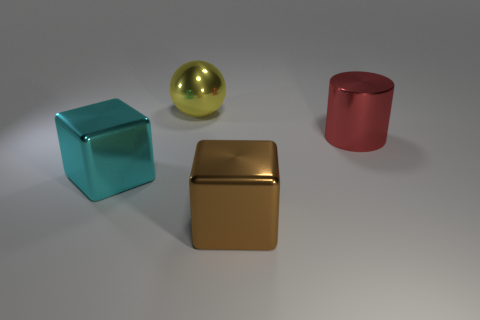Is there anything else that is the same shape as the cyan object?
Make the answer very short. Yes. The large sphere that is the same material as the large red object is what color?
Give a very brief answer. Yellow. How many objects are large green cylinders or large cubes?
Your answer should be very brief. 2. What color is the cube that is behind the big metal block that is to the right of the big block behind the brown cube?
Your response must be concise. Cyan. The large ball is what color?
Ensure brevity in your answer.  Yellow. Are there more big metallic objects in front of the big cyan object than large red objects behind the large brown metallic thing?
Your answer should be compact. No. Does the big brown metallic object have the same shape as the big metal object on the left side of the large metallic sphere?
Offer a very short reply. Yes. There is a metallic thing that is behind the cylinder; is it the same size as the metal cube on the left side of the big yellow shiny sphere?
Provide a succinct answer. Yes. There is a big metal block that is in front of the object that is left of the large yellow sphere; is there a brown shiny object on the right side of it?
Keep it short and to the point. No. Are there fewer brown objects that are left of the large yellow metal object than large brown shiny cubes that are left of the big red cylinder?
Your response must be concise. Yes. 